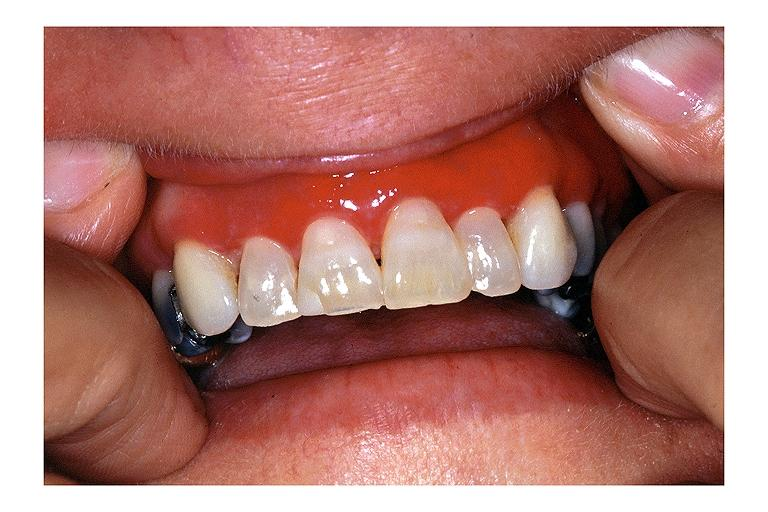s oral present?
Answer the question using a single word or phrase. Yes 